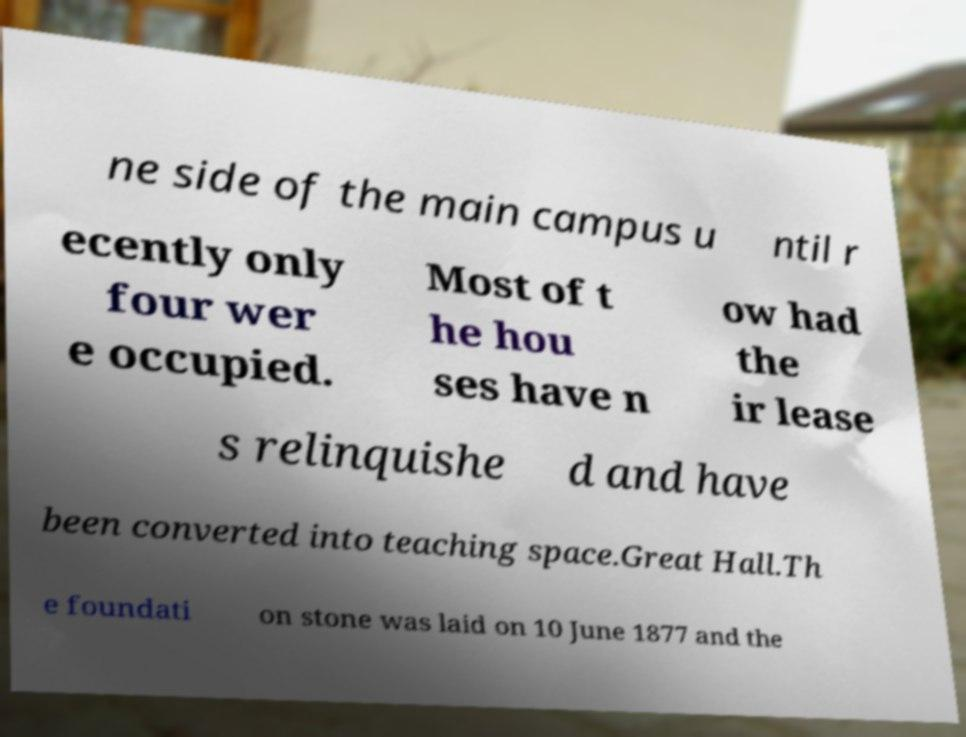Please read and relay the text visible in this image. What does it say? ne side of the main campus u ntil r ecently only four wer e occupied. Most of t he hou ses have n ow had the ir lease s relinquishe d and have been converted into teaching space.Great Hall.Th e foundati on stone was laid on 10 June 1877 and the 